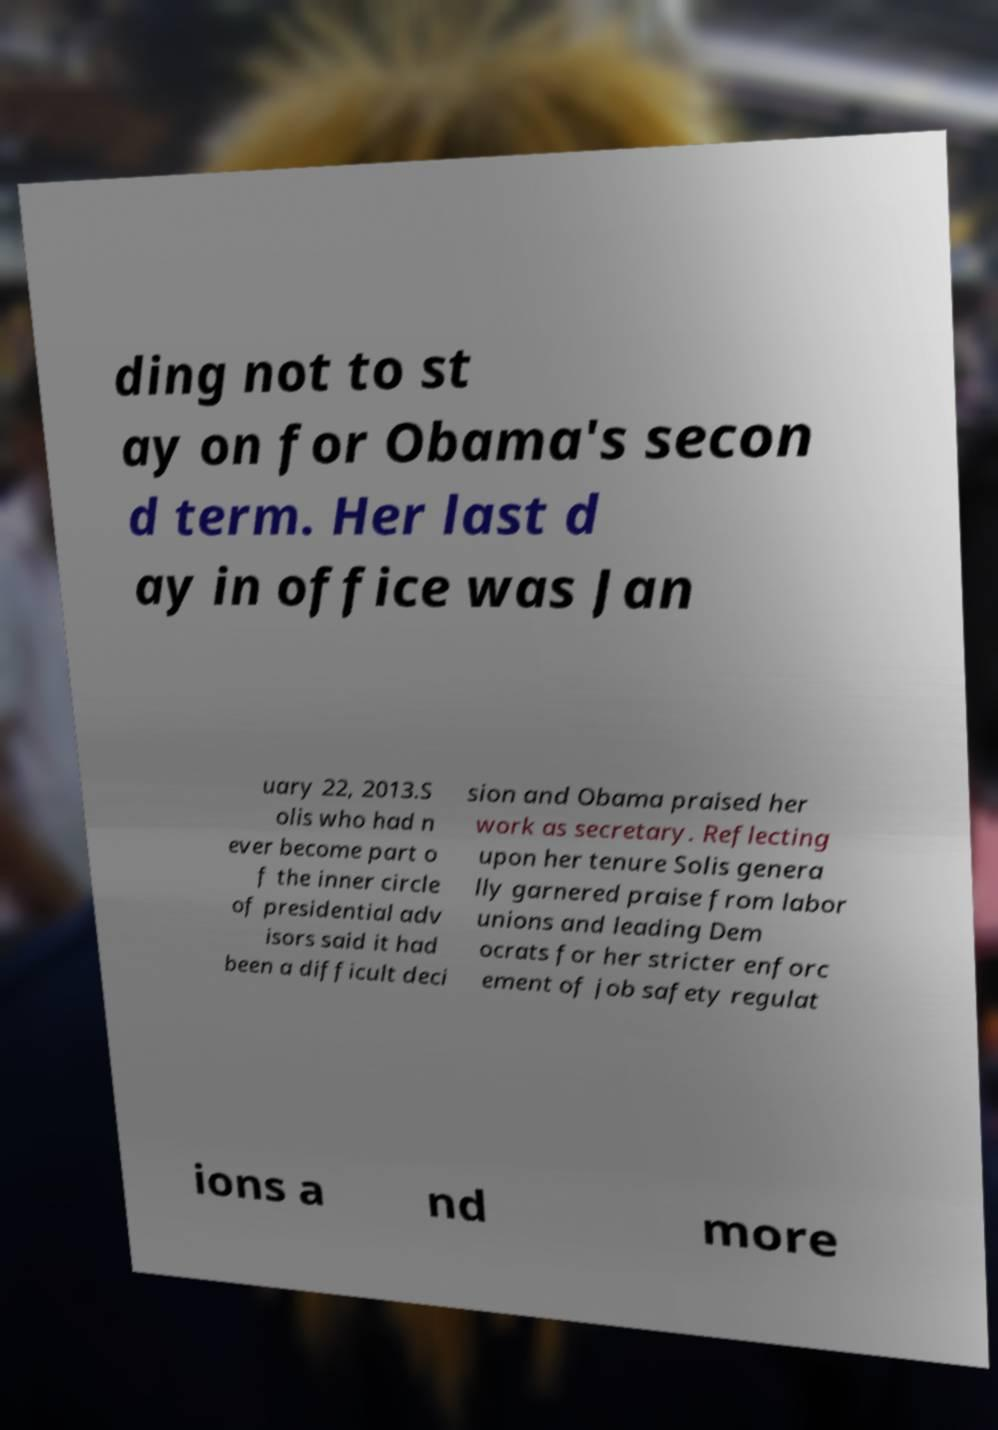Could you extract and type out the text from this image? ding not to st ay on for Obama's secon d term. Her last d ay in office was Jan uary 22, 2013.S olis who had n ever become part o f the inner circle of presidential adv isors said it had been a difficult deci sion and Obama praised her work as secretary. Reflecting upon her tenure Solis genera lly garnered praise from labor unions and leading Dem ocrats for her stricter enforc ement of job safety regulat ions a nd more 